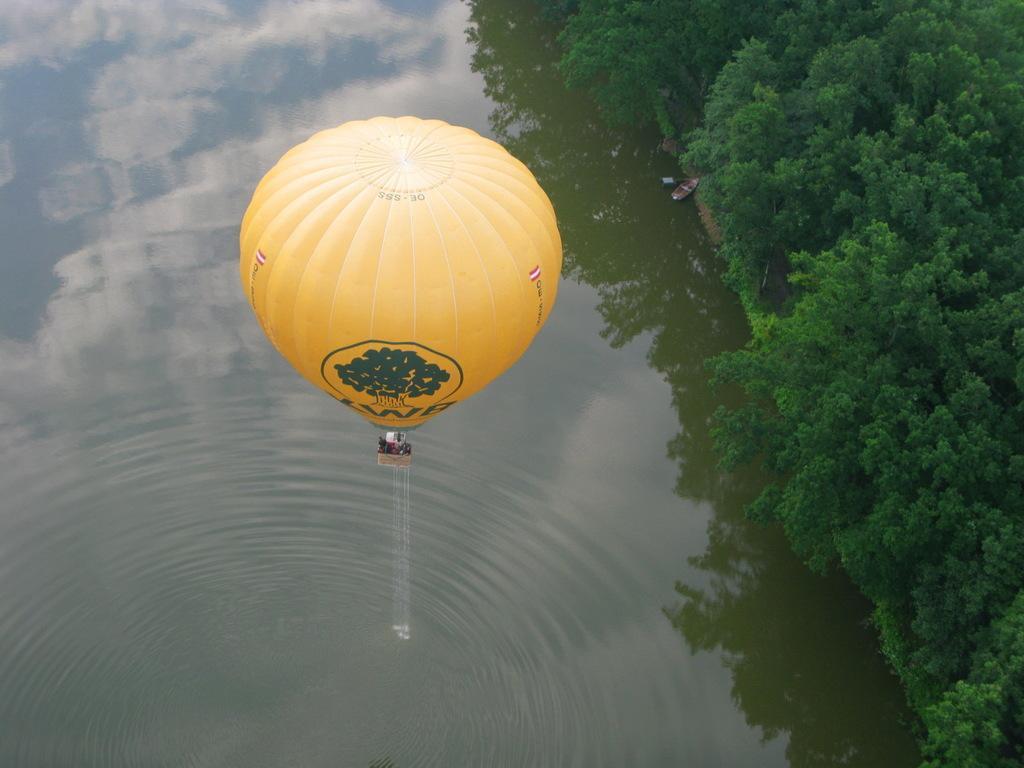In one or two sentences, can you explain what this image depicts? In this image in the center there is a balloon which is yellow in colour. On the right side there are trees and there is water on the left side. 